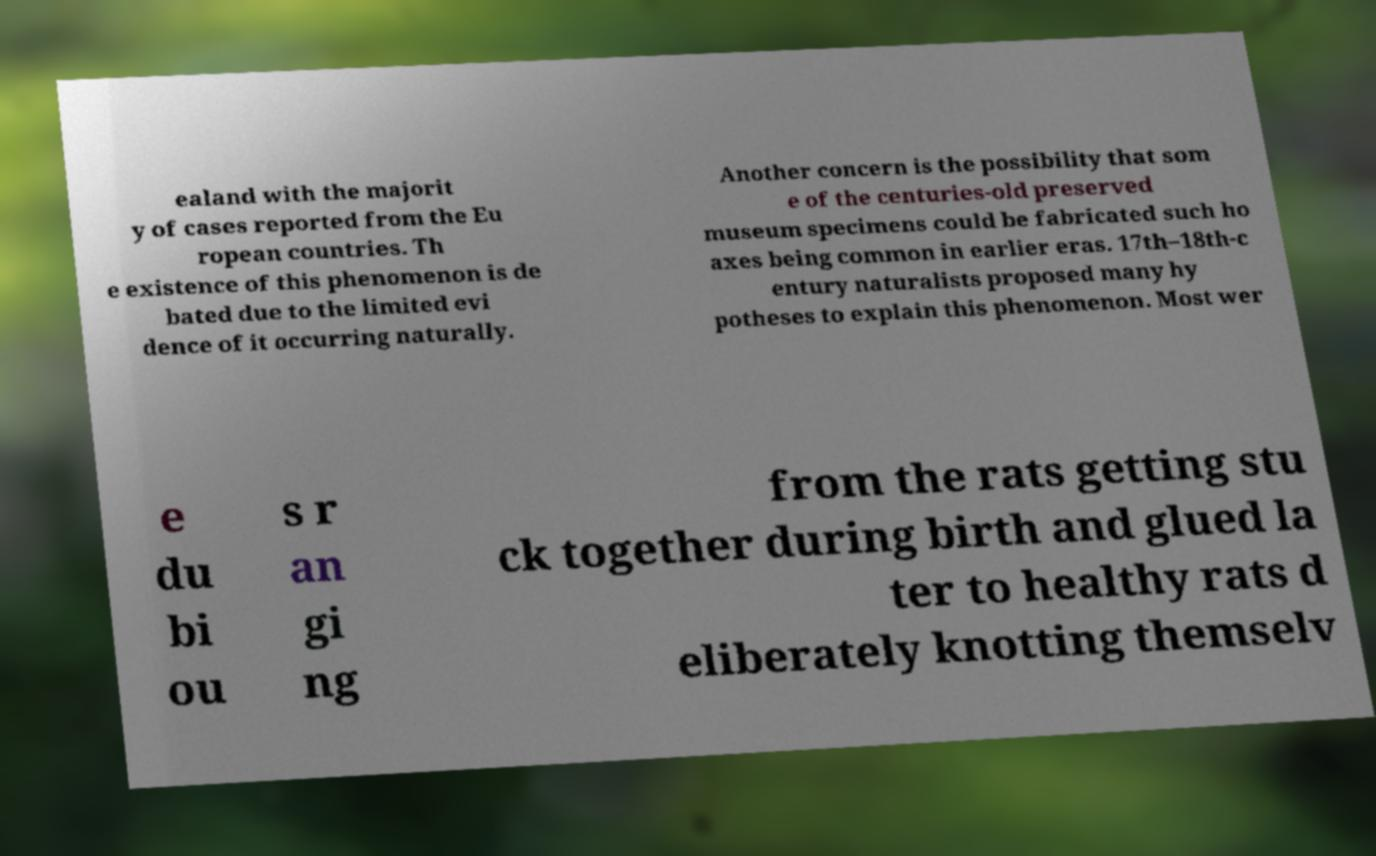Can you read and provide the text displayed in the image?This photo seems to have some interesting text. Can you extract and type it out for me? ealand with the majorit y of cases reported from the Eu ropean countries. Th e existence of this phenomenon is de bated due to the limited evi dence of it occurring naturally. Another concern is the possibility that som e of the centuries-old preserved museum specimens could be fabricated such ho axes being common in earlier eras. 17th–18th-c entury naturalists proposed many hy potheses to explain this phenomenon. Most wer e du bi ou s r an gi ng from the rats getting stu ck together during birth and glued la ter to healthy rats d eliberately knotting themselv 